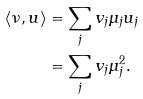<formula> <loc_0><loc_0><loc_500><loc_500>\langle \nu , u \rangle & = \sum _ { j } v _ { j } \mu _ { j } u _ { j } \\ & = \sum _ { j } v _ { j } \mu _ { j } ^ { 2 } .</formula> 